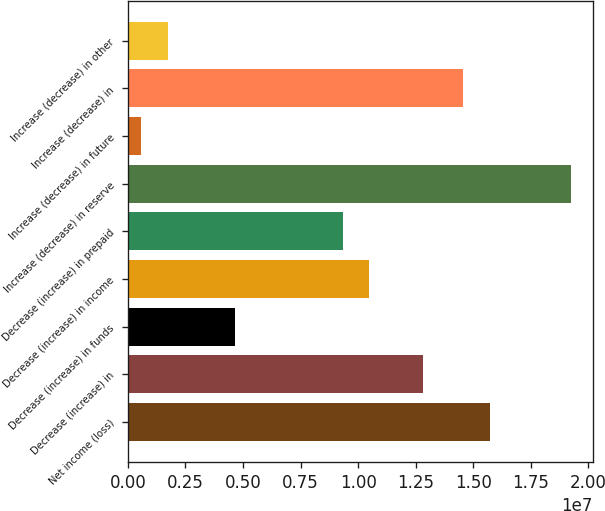<chart> <loc_0><loc_0><loc_500><loc_500><bar_chart><fcel>Net income (loss)<fcel>Decrease (increase) in<fcel>Decrease (increase) in funds<fcel>Decrease (increase) in income<fcel>Decrease (increase) in prepaid<fcel>Increase (decrease) in reserve<fcel>Increase (decrease) in future<fcel>Increase (decrease) in<fcel>Increase (decrease) in other<nl><fcel>1.57365e+07<fcel>1.28226e+07<fcel>4.66372e+06<fcel>1.04915e+07<fcel>9.32593e+06<fcel>1.92331e+07<fcel>584289<fcel>1.45709e+07<fcel>1.74984e+06<nl></chart> 